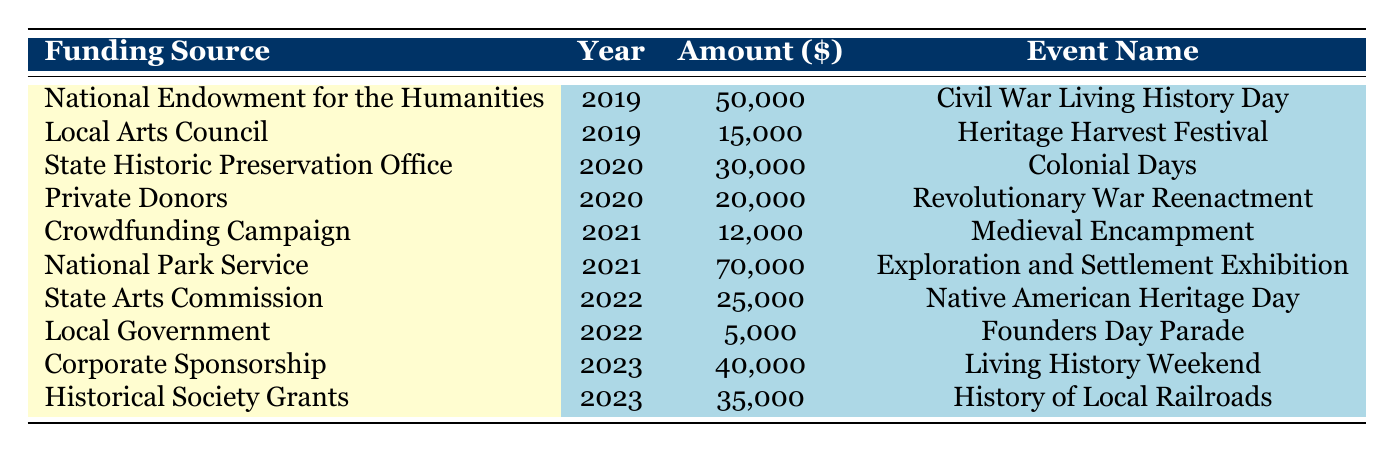What was the highest amount funded for a historical event in the table? The highest amount funded is found by looking at the 'Amount' column. The maximum value is 70,000, which corresponds to the event funded by the National Park Service in 2021.
Answer: 70,000 Which event received funding from the Local Arts Council? By examining the 'Funding Source' column, we can see that the Local Arts Council funded the "Heritage Harvest Festival" in 2019.
Answer: Heritage Harvest Festival What is the total amount funded for historical reenactments across all years? We first identify the amounts funded for events specifically categorized as historical reenactments: 50,000 (Civil War Living History Day) + 20,000 (Revolutionary War Reenactment) + 40,000 (Living History Weekend) = 110,000.
Answer: 110,000 Was there any funding for a parade in 2022? By searching through the data, we see that the Local Government funded the "Founders Day Parade" in 2022, confirming that there was indeed funding for a parade that year.
Answer: Yes What is the average amount funded per event type based on the table data? We sum the amounts funded for each event type: Historical Reenactments (50,000 + 20,000 + 40,000), Cultural Festivals (15,000), Historical Fairs (30,000), Community Events (12,000), Historical Exhibitions (70,000), Cultural Showcases (25,000), and Parades (5,000). There are 10 total data points, so the average is calculated by dividing the total by the number of events, giving an average of 25,000.
Answer: 25,000 Which year saw the lowest funding amount? By reviewing the funding amounts for each year, we find that the year 2022 has the lowest amount funded, at 5,000 for the Founders Day Parade.
Answer: 2022 What percentage of total funding comes from the National Park Service? The total funding from all sources is 50,000 + 15,000 + 30,000 + 20,000 + 12,000 + 70,000 + 25,000 + 5,000 + 40,000 + 35,000 =  332,000. The National Park Service contributed 70,000. Thus, the percentage is (70,000 / 332,000) * 100 ≈ 21.06%.
Answer: Approximately 21.06% Which types of events received funding in 2023? We can identify events in 2023 by checking the 'Year' column for 2023. The events listed are "Living History Weekend" and "History of Local Railroads." Therefore, both outdoor festivals and seminars received funding that year.
Answer: Outdoor Festival, Seminar How many times did Private Donors contribute funding in the table? By scanning through the funding sources, we see that Private Donors contributed once (for the Revolutionary War Reenactment in 2020).
Answer: Once How does the funding from the National Endowment for the Humanities compare to that of the State Historic Preservation Office? The National Endowment for the Humanities funded 50,000 in 2019, while the State Historic Preservation Office funded 30,000 in 2020. Comparing these numbers shows that the funding from the National Endowment for the Humanities is greater by 20,000.
Answer: Greater by 20,000 